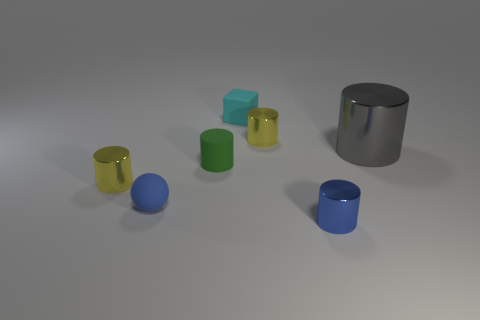Subtract all tiny yellow cylinders. How many cylinders are left? 3 Add 1 yellow metal things. How many objects exist? 8 Subtract all green cylinders. How many cylinders are left? 4 Subtract 1 blocks. How many blocks are left? 0 Subtract all gray spheres. Subtract all red cubes. How many spheres are left? 1 Subtract all green balls. How many yellow cylinders are left? 2 Subtract all green rubber balls. Subtract all tiny things. How many objects are left? 1 Add 2 shiny cylinders. How many shiny cylinders are left? 6 Add 7 blue balls. How many blue balls exist? 8 Subtract 0 brown cylinders. How many objects are left? 7 